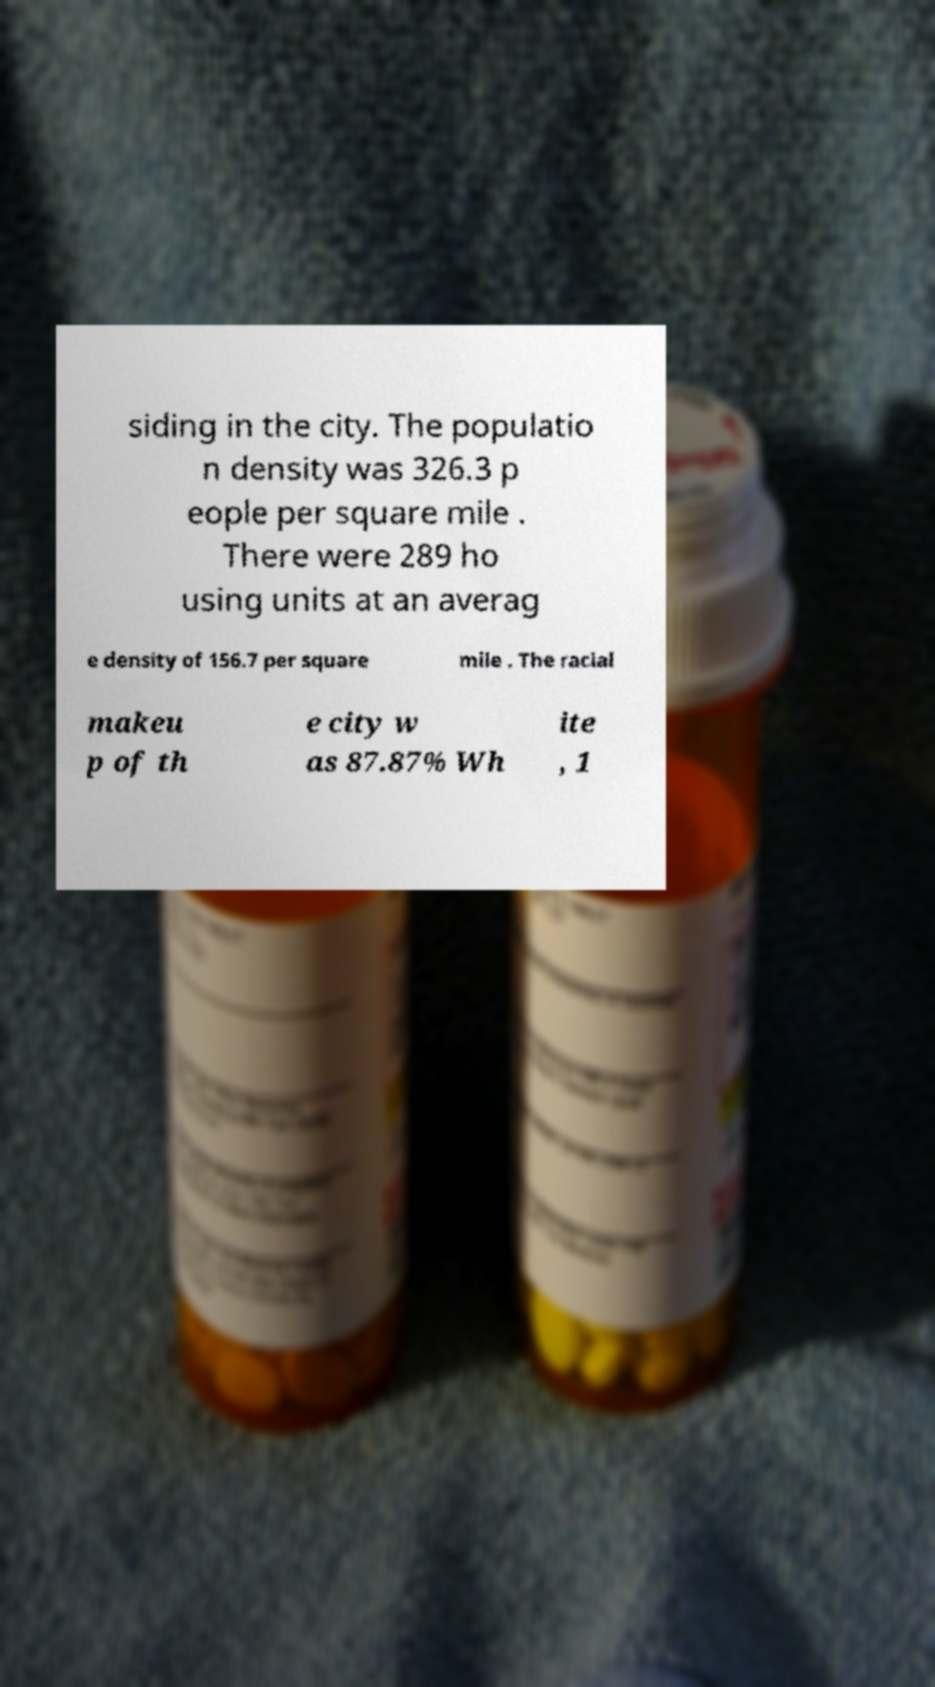There's text embedded in this image that I need extracted. Can you transcribe it verbatim? siding in the city. The populatio n density was 326.3 p eople per square mile . There were 289 ho using units at an averag e density of 156.7 per square mile . The racial makeu p of th e city w as 87.87% Wh ite , 1 